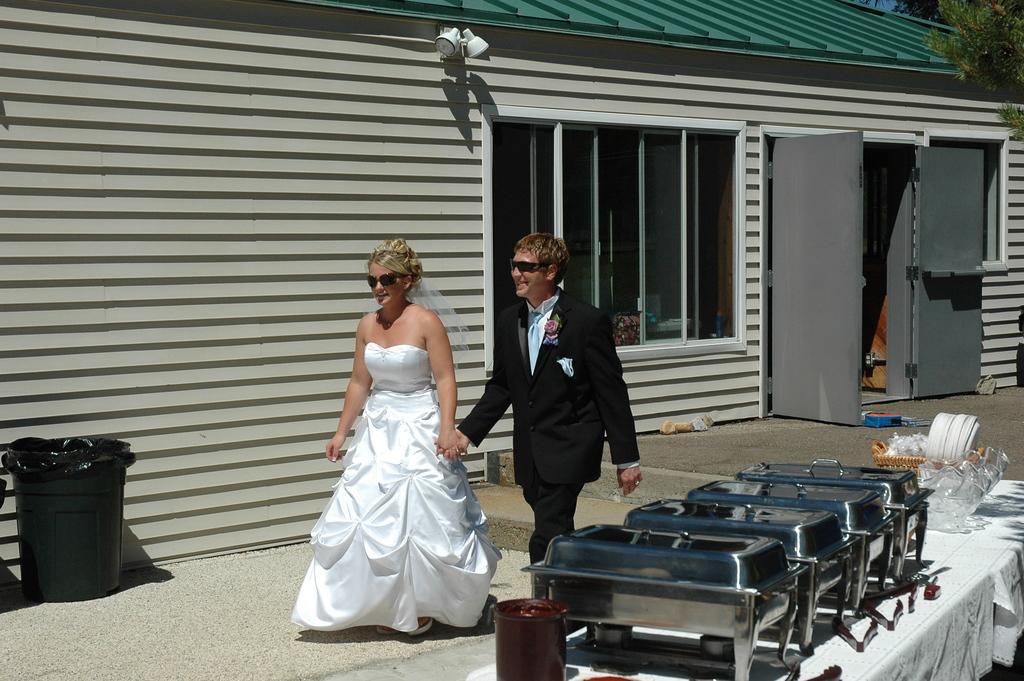In one or two sentences, can you explain what this image depicts? In this image, there are a few people. We can see the ground with some objects. We can also see a dustbin on the left. We can see a table covered with a white cloth with some objects like containers and plates are placed on it. We can see a house with doors and windows. We can also see a white colored object. We can see a tree on the top right. 